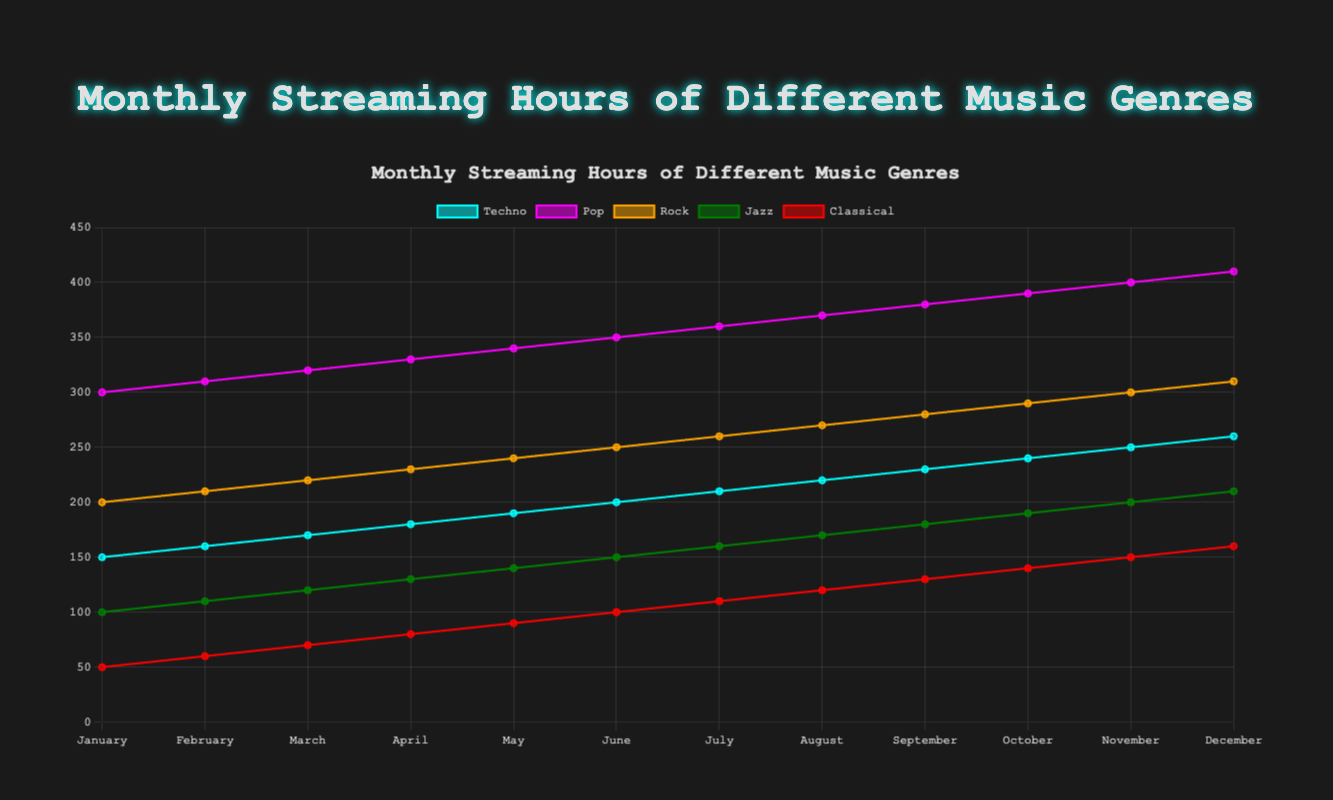What is the title of the figure? The title is displayed at the top center of the figure, and it reads "Monthly Streaming Hours of Different Music Genres."
Answer: Monthly Streaming Hours of Different Music Genres Which genre had the highest streaming hours in January? To find the genre with the highest streaming hours in January, look at the data points for each genre for this month and find the maximum value. Pop had the highest streaming hours at 300.
Answer: Pop How many months are displayed in the figure? The number of months on the x-axis can be counted to determine this. There are 12 months displayed from January to December.
Answer: 12 How do the streaming hours for Techno compare between January and December? Look at the values for Techno in January (150 hours) and December (260 hours). The streaming hours increased from January to December.
Answer: Increased What's the total streaming hours for Rock in the first quarter (January to March)? Summing up the streaming hours for Rock in January (200), February (210), and March (220), we get 200 + 210 + 220 = 630.
Answer: 630 Which genre shows the steady increase over the months? By visually inspecting the trends for each genre, all seem to show a steady increase over the months. However, Classical starts at a low point and steadily increases each month.
Answer: Classical What's the difference in streaming hours between Rock and Jazz in August? To find the difference, subtract Jazz hours (170) from Rock hours (270) in August. 270 - 170 = 100.
Answer: 100 Which month had the highest streaming hours for Jazz? By inspecting the trend line for Jazz, which is green, it is at its highest in December with 210 streaming hours.
Answer: December What is the average monthly streaming hours for Classical in the second half of the year (July to December)? Sum the streaming hours and then divide by 6. (110 + 120 + 130 + 140 + 150 + 160) / 6 = 810 / 6 = 135.
Answer: 135 Which genre had more streaming hours in November, Techno or Classical? Comparing Techno (250) and Classical (150) in November, Techno had more streaming hours.
Answer: Techno 